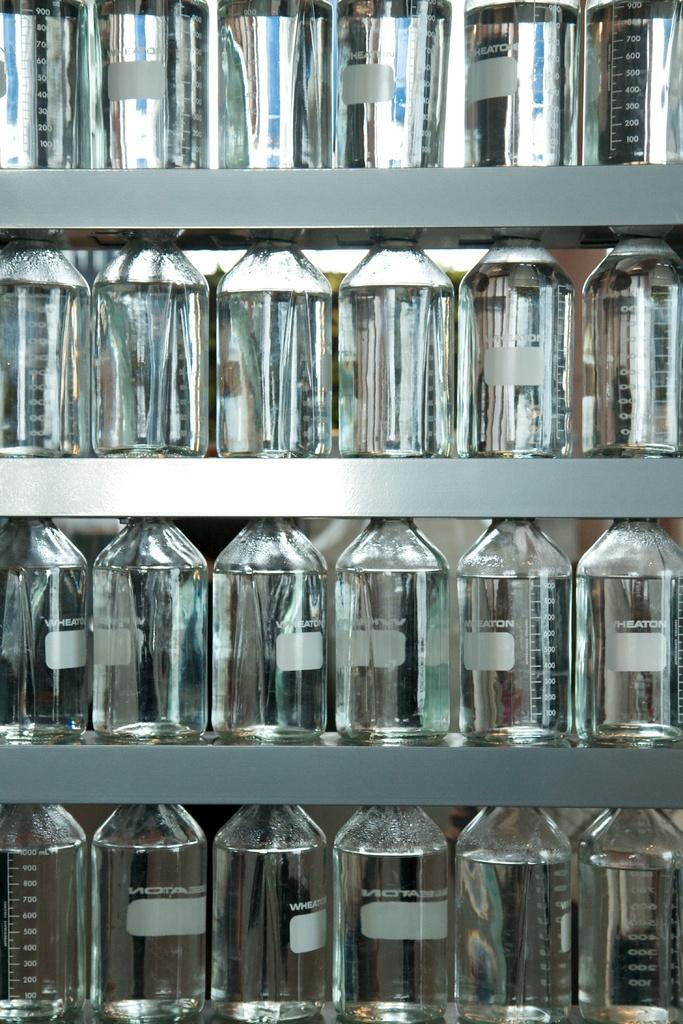What type of containers are on the shelf in the image? There are glass bottles on a shelf in the image. What material are the containers made of? The containers are made of glass. Where are the containers located in the image? The containers are on a shelf in the image. What type of gold trade is depicted in the image? There is no gold trade depicted in the image; it features glass bottles on a shelf. What type of suit is visible on the shelf in the image? There is no suit present in the image; it features glass bottles on a shelf. 